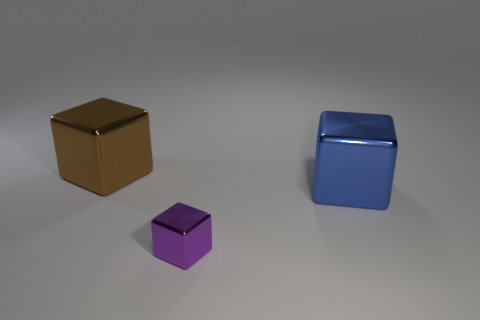Are there more big metallic things than big blue metal objects?
Give a very brief answer. Yes. What material is the large blue thing?
Keep it short and to the point. Metal. Are there any other things that are the same size as the brown block?
Your answer should be very brief. Yes. What is the size of the brown object that is the same shape as the blue metallic thing?
Provide a short and direct response. Large. Are there any brown objects that are on the right side of the large metallic object to the right of the small purple thing?
Provide a succinct answer. No. What number of other things are the same shape as the blue object?
Provide a short and direct response. 2. Are there more blue metallic things left of the brown shiny cube than purple blocks behind the blue cube?
Ensure brevity in your answer.  No. There is a metallic thing behind the big blue thing; is its size the same as the metal thing that is in front of the blue shiny object?
Provide a succinct answer. No. The blue shiny thing is what shape?
Offer a very short reply. Cube. What color is the small block that is the same material as the big blue thing?
Give a very brief answer. Purple. 